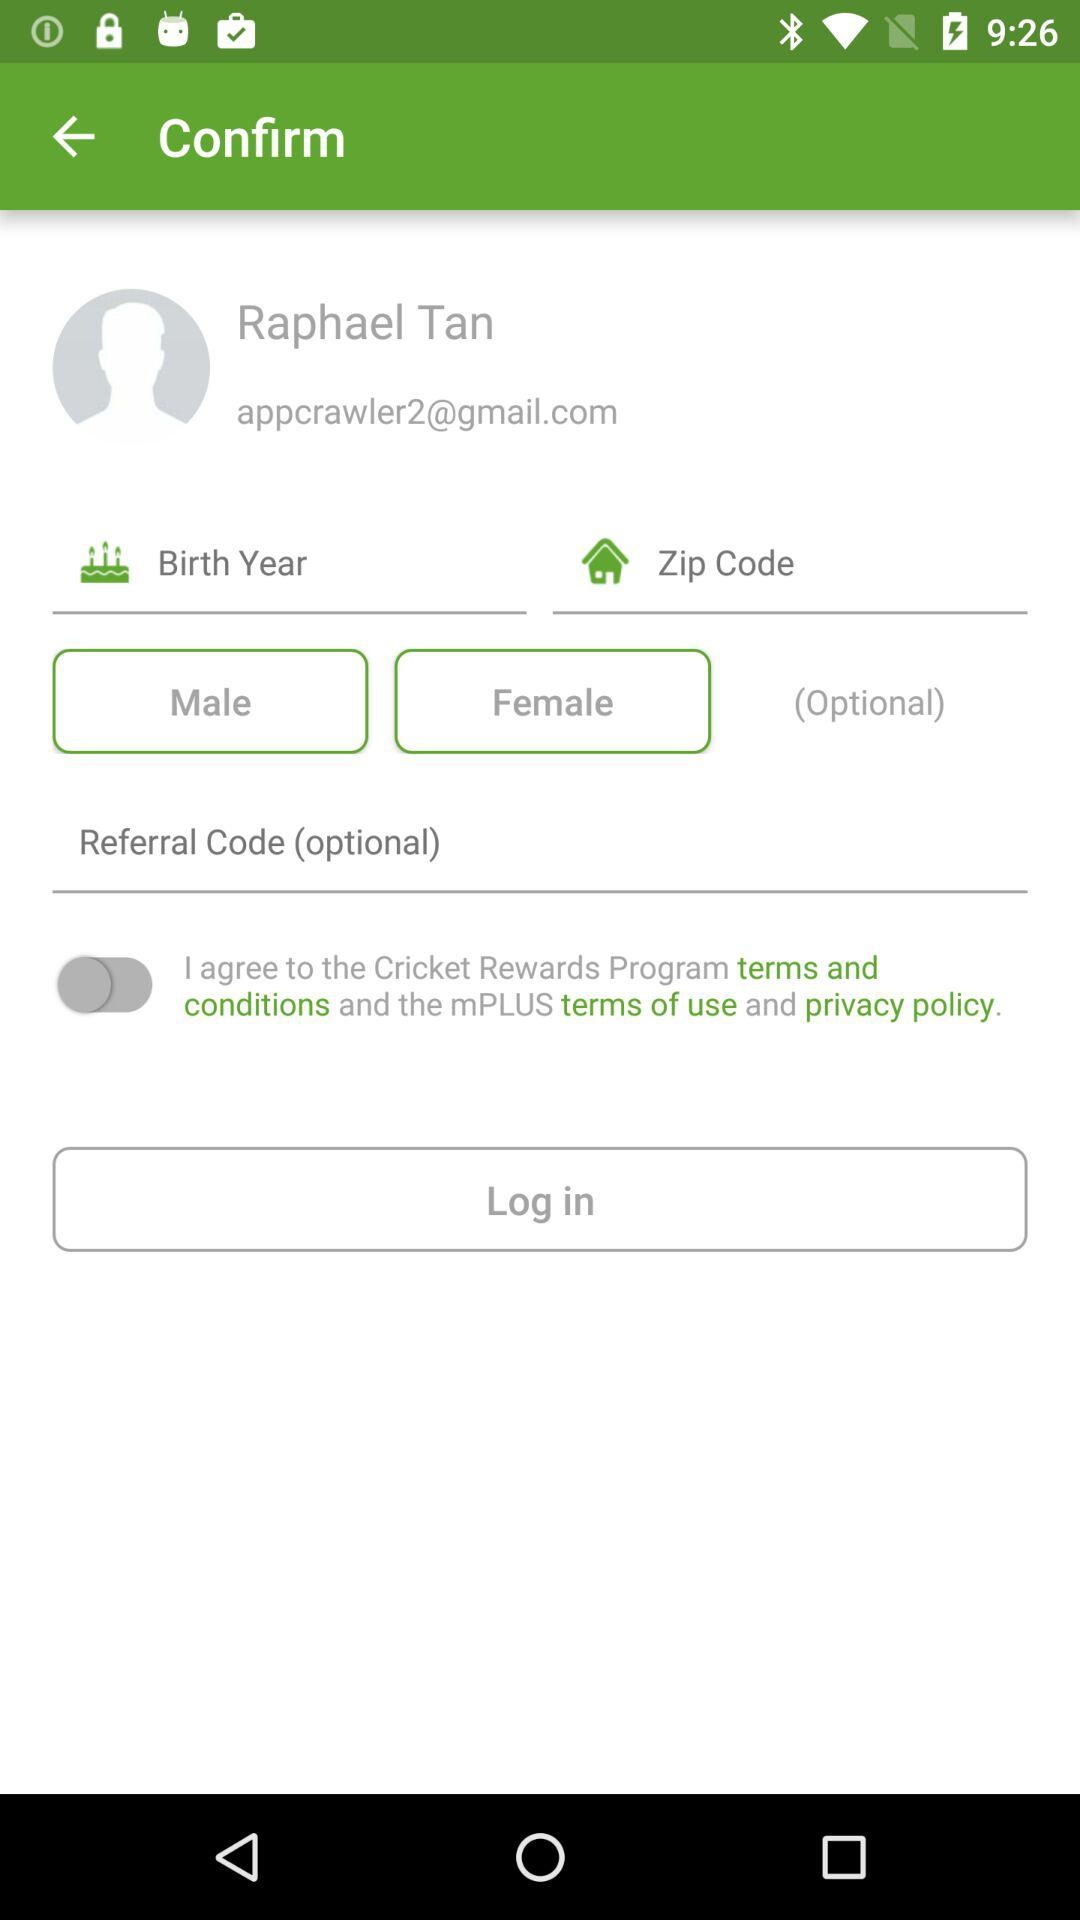What is the status of the option that includes agreement to the Cricket Rewards Program's "terms and conditions" and the mPLUS's “terms of use” and “privacy policy”? The status is "off". 